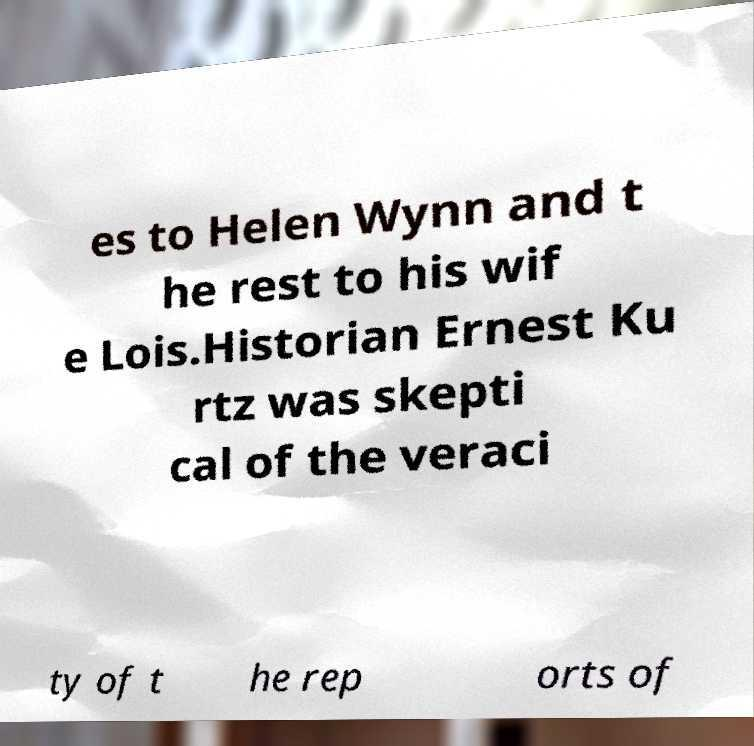Could you assist in decoding the text presented in this image and type it out clearly? es to Helen Wynn and t he rest to his wif e Lois.Historian Ernest Ku rtz was skepti cal of the veraci ty of t he rep orts of 